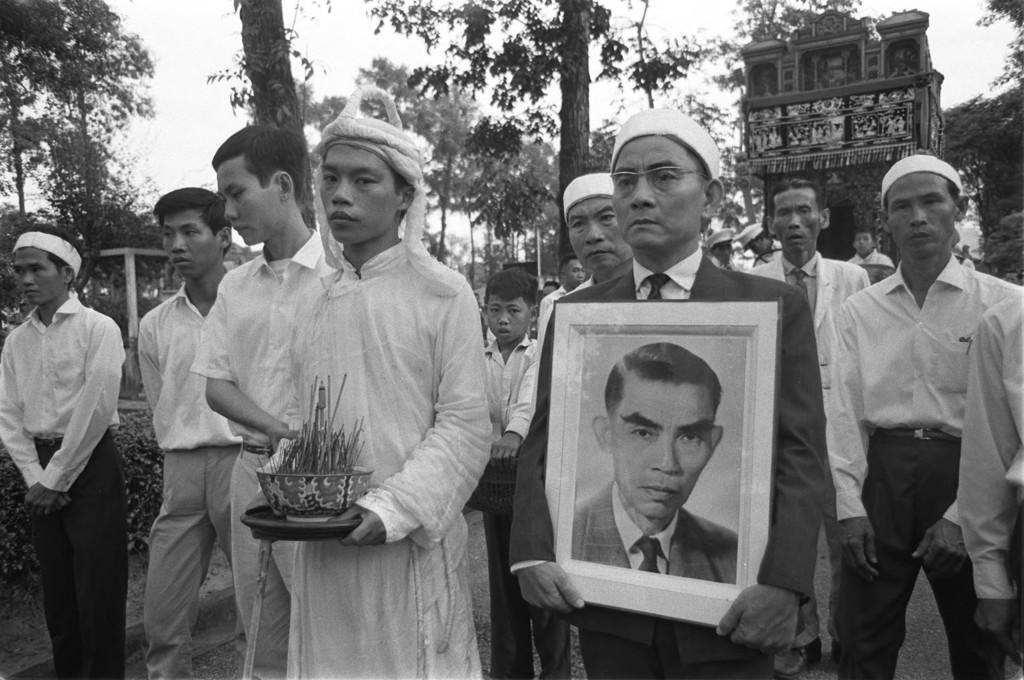In one or two sentences, can you explain what this image depicts? There is a person holding a photograph and another person holding an object in the foreground area of the image, there are people, trees, building structure and the sky in the background. 